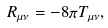Convert formula to latex. <formula><loc_0><loc_0><loc_500><loc_500>R _ { \mu \nu } = - 8 \pi T _ { \mu \nu } ,</formula> 